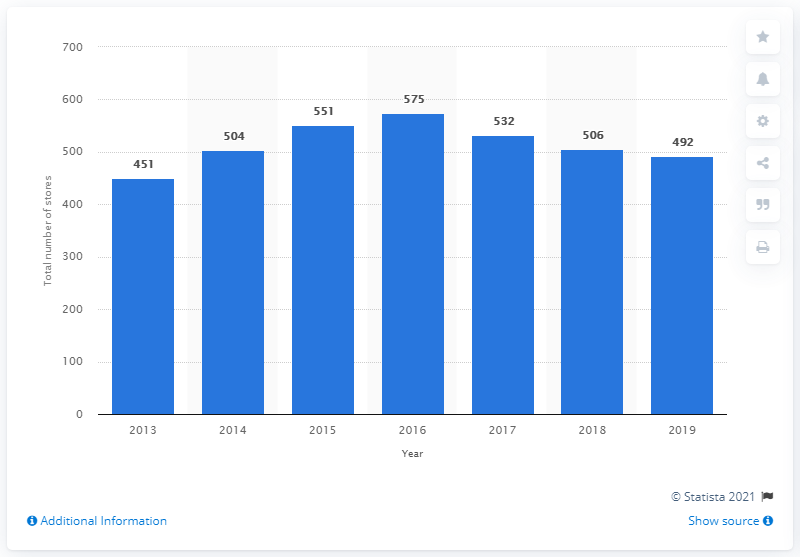Highlight a few significant elements in this photo. As of March 2, 2020, J. Crew operated a total of 492 stores. 